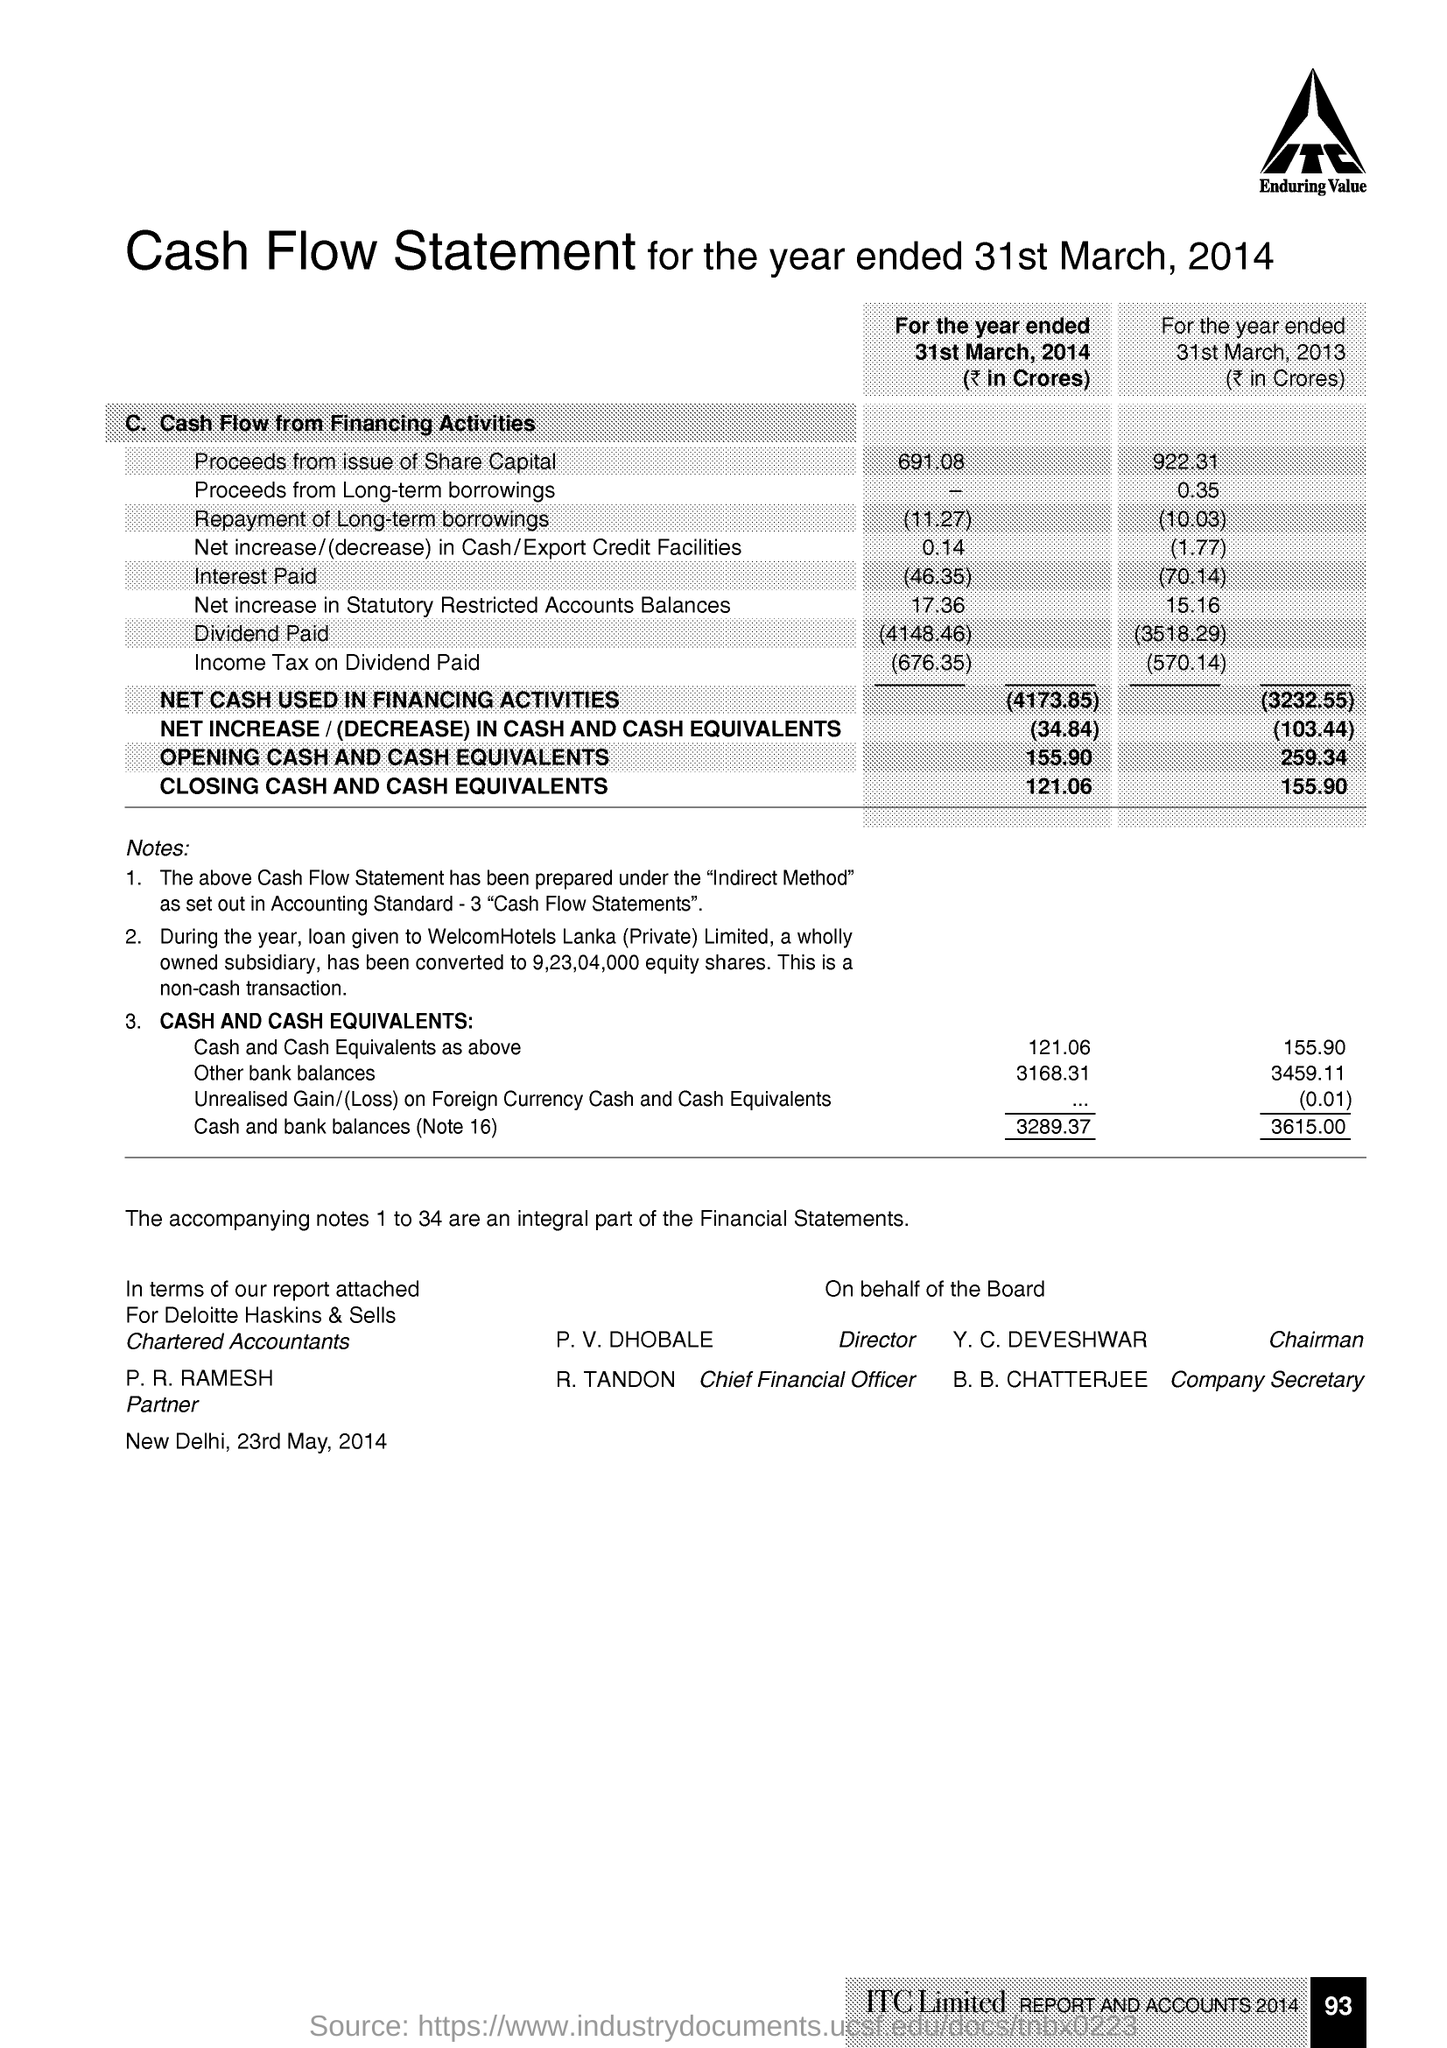Specify some key components in this picture. The Chairman of the company is Y. C. DEVESHWAR. The person in charge of the company is P. V. Dhoble. The Company Secretary is B. B. Chatterjee. The person named R. Tandon is the Chief Financial Officer. 